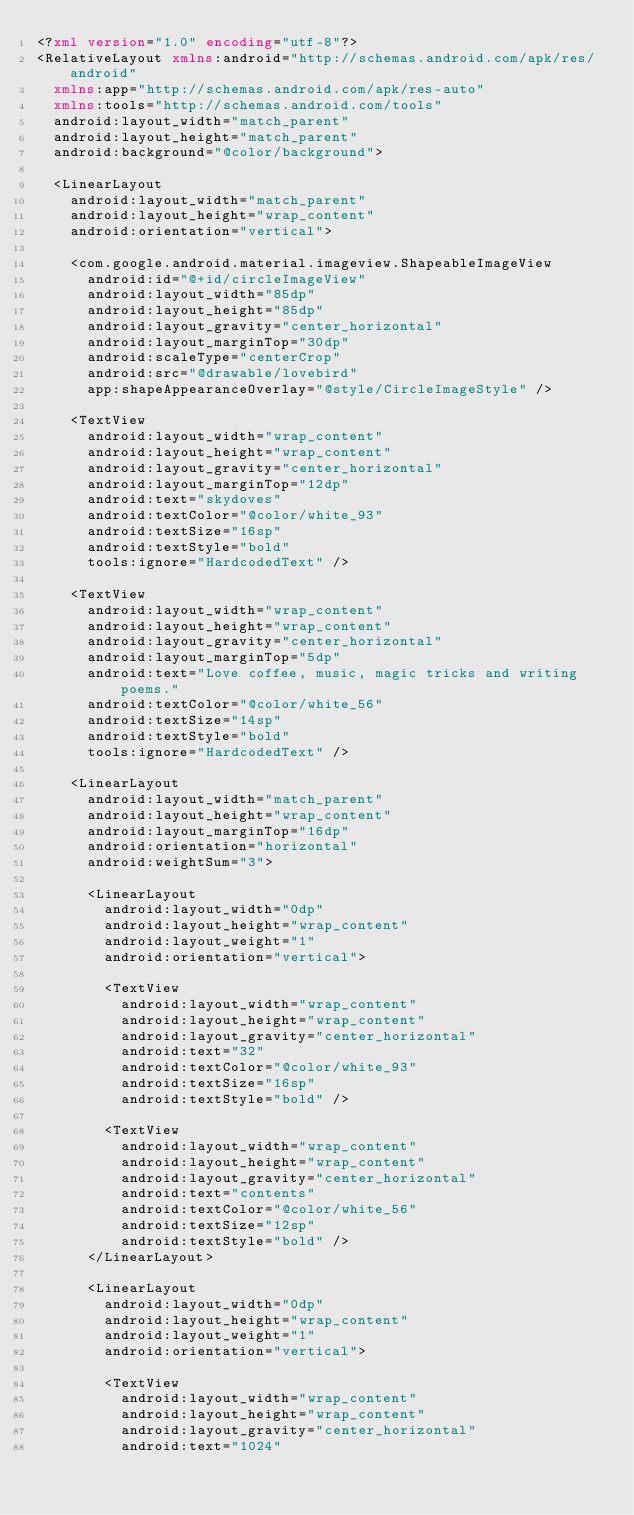<code> <loc_0><loc_0><loc_500><loc_500><_XML_><?xml version="1.0" encoding="utf-8"?>
<RelativeLayout xmlns:android="http://schemas.android.com/apk/res/android"
  xmlns:app="http://schemas.android.com/apk/res-auto"
  xmlns:tools="http://schemas.android.com/tools"
  android:layout_width="match_parent"
  android:layout_height="match_parent"
  android:background="@color/background">

  <LinearLayout
    android:layout_width="match_parent"
    android:layout_height="wrap_content"
    android:orientation="vertical">

    <com.google.android.material.imageview.ShapeableImageView
      android:id="@+id/circleImageView"
      android:layout_width="85dp"
      android:layout_height="85dp"
      android:layout_gravity="center_horizontal"
      android:layout_marginTop="30dp"
      android:scaleType="centerCrop"
      android:src="@drawable/lovebird"
      app:shapeAppearanceOverlay="@style/CircleImageStyle" />

    <TextView
      android:layout_width="wrap_content"
      android:layout_height="wrap_content"
      android:layout_gravity="center_horizontal"
      android:layout_marginTop="12dp"
      android:text="skydoves"
      android:textColor="@color/white_93"
      android:textSize="16sp"
      android:textStyle="bold"
      tools:ignore="HardcodedText" />

    <TextView
      android:layout_width="wrap_content"
      android:layout_height="wrap_content"
      android:layout_gravity="center_horizontal"
      android:layout_marginTop="5dp"
      android:text="Love coffee, music, magic tricks and writing poems."
      android:textColor="@color/white_56"
      android:textSize="14sp"
      android:textStyle="bold"
      tools:ignore="HardcodedText" />

    <LinearLayout
      android:layout_width="match_parent"
      android:layout_height="wrap_content"
      android:layout_marginTop="16dp"
      android:orientation="horizontal"
      android:weightSum="3">

      <LinearLayout
        android:layout_width="0dp"
        android:layout_height="wrap_content"
        android:layout_weight="1"
        android:orientation="vertical">

        <TextView
          android:layout_width="wrap_content"
          android:layout_height="wrap_content"
          android:layout_gravity="center_horizontal"
          android:text="32"
          android:textColor="@color/white_93"
          android:textSize="16sp"
          android:textStyle="bold" />

        <TextView
          android:layout_width="wrap_content"
          android:layout_height="wrap_content"
          android:layout_gravity="center_horizontal"
          android:text="contents"
          android:textColor="@color/white_56"
          android:textSize="12sp"
          android:textStyle="bold" />
      </LinearLayout>

      <LinearLayout
        android:layout_width="0dp"
        android:layout_height="wrap_content"
        android:layout_weight="1"
        android:orientation="vertical">

        <TextView
          android:layout_width="wrap_content"
          android:layout_height="wrap_content"
          android:layout_gravity="center_horizontal"
          android:text="1024"</code> 